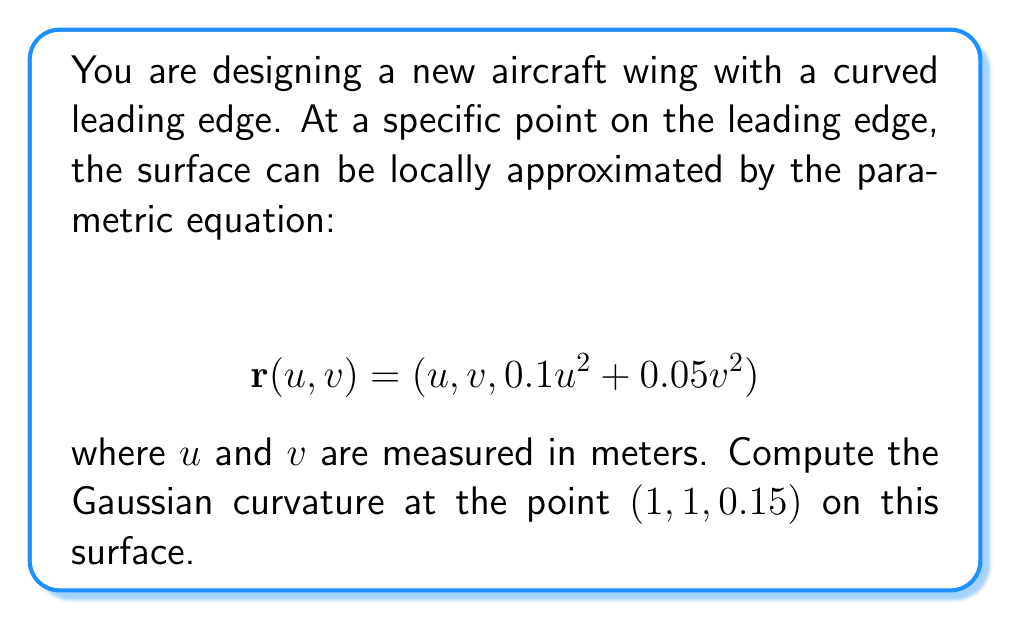Solve this math problem. To compute the Gaussian curvature, we need to follow these steps:

1) First, we need to calculate the partial derivatives of $\mathbf{r}$ with respect to $u$ and $v$:

   $\mathbf{r}_u = (1, 0, 0.2u)$
   $\mathbf{r}_v = (0, 1, 0.1v)$

2) Next, we calculate the second partial derivatives:

   $\mathbf{r}_{uu} = (0, 0, 0.2)$
   $\mathbf{r}_{uv} = (0, 0, 0)$
   $\mathbf{r}_{vv} = (0, 0, 0.1)$

3) Now we can compute the coefficients of the first fundamental form:

   $E = \mathbf{r}_u \cdot \mathbf{r}_u = 1 + 0.04u^2$
   $F = \mathbf{r}_u \cdot \mathbf{r}_v = 0.02uv$
   $G = \mathbf{r}_v \cdot \mathbf{r}_v = 1 + 0.01v^2$

4) And the coefficients of the second fundamental form:

   $L = \frac{\mathbf{r}_{uu} \cdot (\mathbf{r}_u \times \mathbf{r}_v)}{|\mathbf{r}_u \times \mathbf{r}_v|} = \frac{0.2}{\sqrt{1 + 0.04u^2 + 0.01v^2}}$
   
   $M = \frac{\mathbf{r}_{uv} \cdot (\mathbf{r}_u \times \mathbf{r}_v)}{|\mathbf{r}_u \times \mathbf{r}_v|} = 0$
   
   $N = \frac{\mathbf{r}_{vv} \cdot (\mathbf{r}_u \times \mathbf{r}_v)}{|\mathbf{r}_u \times \mathbf{r}_v|} = \frac{0.1}{\sqrt{1 + 0.04u^2 + 0.01v^2}}$

5) The Gaussian curvature is given by:

   $K = \frac{LN - M^2}{EG - F^2}$

6) Substituting the values at the point (1, 1, 0.15):

   $E = 1.04$, $F = 0.02$, $G = 1.01$
   $L = \frac{0.2}{\sqrt{1.05}} \approx 0.1952$, $M = 0$, $N = \frac{0.1}{\sqrt{1.05}} \approx 0.0976$

7) Now we can compute K:

   $K = \frac{(0.1952)(0.0976) - 0^2}{(1.04)(1.01) - 0.02^2} \approx 0.0182$
Answer: The Gaussian curvature at the point (1, 1, 0.15) on the surface is approximately 0.0182 m^(-2). 